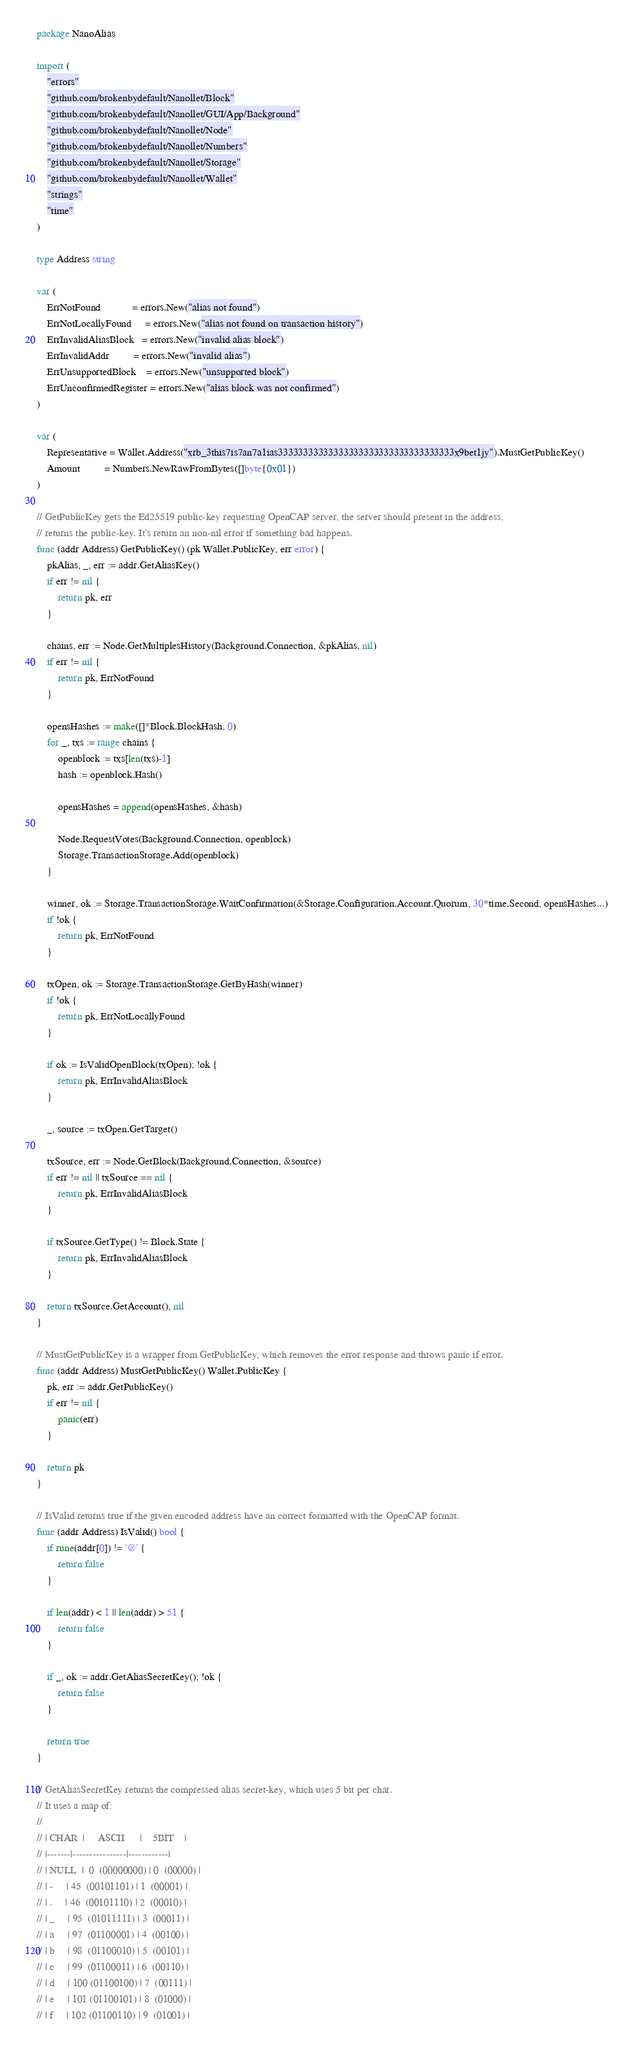Convert code to text. <code><loc_0><loc_0><loc_500><loc_500><_Go_>package NanoAlias

import (
	"errors"
	"github.com/brokenbydefault/Nanollet/Block"
	"github.com/brokenbydefault/Nanollet/GUI/App/Background"
	"github.com/brokenbydefault/Nanollet/Node"
	"github.com/brokenbydefault/Nanollet/Numbers"
	"github.com/brokenbydefault/Nanollet/Storage"
	"github.com/brokenbydefault/Nanollet/Wallet"
	"strings"
	"time"
)

type Address string

var (
	ErrNotFound            = errors.New("alias not found")
	ErrNotLocallyFound     = errors.New("alias not found on transaction history")
	ErrInvalidAliasBlock   = errors.New("invalid alias block")
	ErrInvalidAddr         = errors.New("invalid alias")
	ErrUnsupportedBlock    = errors.New("unsupported block")
	ErrUnconfirmedRegister = errors.New("alias block was not confirmed")
)

var (
	Representative = Wallet.Address("xrb_3this7is7an7a1ias33333333333333333333333333333333333x9bet1jy").MustGetPublicKey()
	Amount         = Numbers.NewRawFromBytes([]byte{0x01})
)

// GetPublicKey gets the Ed25519 public-key requesting OpenCAP server, the server should present in the address,
// returns the public-key. It's return an non-nil error if something bad happens.
func (addr Address) GetPublicKey() (pk Wallet.PublicKey, err error) {
	pkAlias, _, err := addr.GetAliasKey()
	if err != nil {
		return pk, err
	}

	chains, err := Node.GetMultiplesHistory(Background.Connection, &pkAlias, nil)
	if err != nil {
		return pk, ErrNotFound
	}

	opensHashes := make([]*Block.BlockHash, 0)
	for _, txs := range chains {
		openblock := txs[len(txs)-1]
		hash := openblock.Hash()

		opensHashes = append(opensHashes, &hash)

		Node.RequestVotes(Background.Connection, openblock)
		Storage.TransactionStorage.Add(openblock)
	}

	winner, ok := Storage.TransactionStorage.WaitConfirmation(&Storage.Configuration.Account.Quorum, 30*time.Second, opensHashes...)
	if !ok {
		return pk, ErrNotFound
	}

	txOpen, ok := Storage.TransactionStorage.GetByHash(winner)
	if !ok {
		return pk, ErrNotLocallyFound
	}

	if ok := IsValidOpenBlock(txOpen); !ok {
		return pk, ErrInvalidAliasBlock
	}

	_, source := txOpen.GetTarget()

	txSource, err := Node.GetBlock(Background.Connection, &source)
	if err != nil || txSource == nil {
		return pk, ErrInvalidAliasBlock
	}

	if txSource.GetType() != Block.State {
		return pk, ErrInvalidAliasBlock
	}

	return txSource.GetAccount(), nil
}

// MustGetPublicKey is a wrapper from GetPublicKey, which removes the error response and throws panic if error.
func (addr Address) MustGetPublicKey() Wallet.PublicKey {
	pk, err := addr.GetPublicKey()
	if err != nil {
		panic(err)
	}

	return pk
}

// IsValid returns true if the given encoded address have an correct formatted with the OpenCAP format.
func (addr Address) IsValid() bool {
	if rune(addr[0]) != '@' {
		return false
	}

	if len(addr) < 1 || len(addr) > 51 {
		return false
	}

	if _, ok := addr.GetAliasSecretKey(); !ok {
		return false
	}

	return true
}

// GetAliasSecretKey returns the compressed alias secret-key, which uses 5 bit per char.
// It uses a map of:
//
// | CHAR  |     ASCII      |    5BIT    |
// |-------|----------------|------------|
// | NULL  |  0  (00000000) | 0  (00000) |
// | -     | 45  (00101101) | 1  (00001) |
// | .     | 46  (00101110) | 2  (00010) |
// | _     | 95  (01011111) | 3  (00011) |
// | a     | 97  (01100001) | 4  (00100) |
// | b     | 98  (01100010) | 5  (00101) |
// | c     | 99  (01100011) | 6  (00110) |
// | d     | 100 (01100100) | 7  (00111) |
// | e     | 101 (01100101) | 8  (01000) |
// | f     | 102 (01100110) | 9  (01001) |</code> 